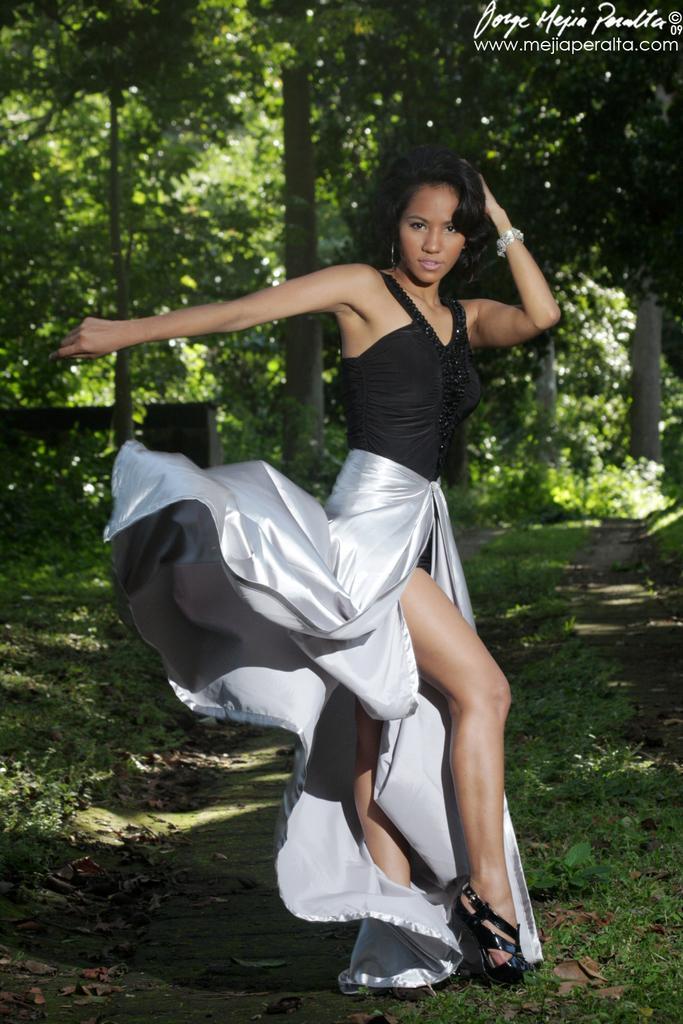Describe this image in one or two sentences. In this image I can see a woman is standing, she wore black top and white color frock. At the back side there are trees, at the top there is the watermark. 